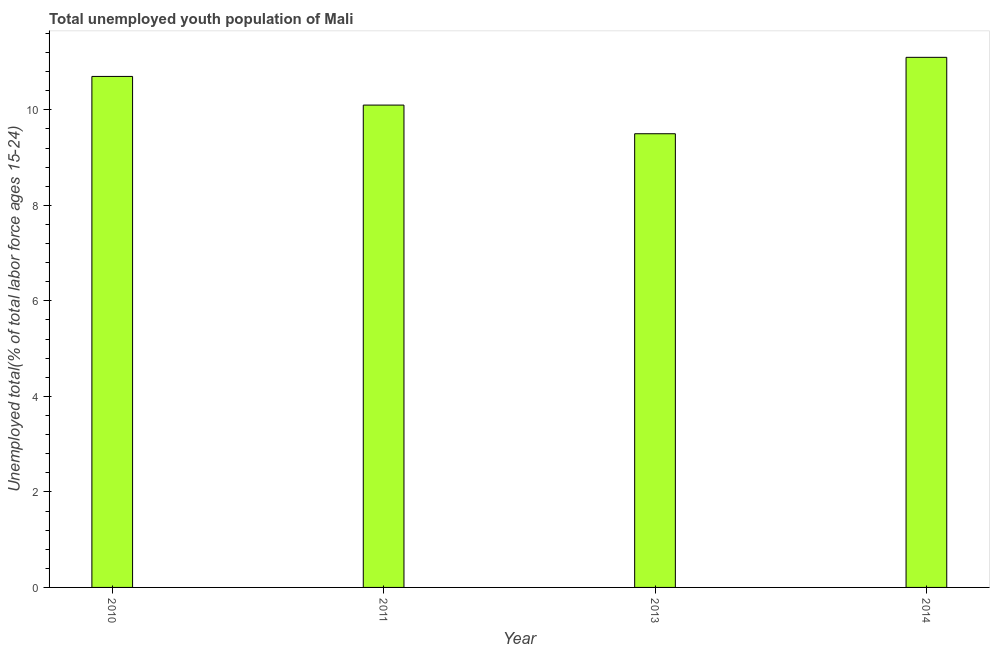Does the graph contain grids?
Provide a succinct answer. No. What is the title of the graph?
Ensure brevity in your answer.  Total unemployed youth population of Mali. What is the label or title of the Y-axis?
Offer a very short reply. Unemployed total(% of total labor force ages 15-24). Across all years, what is the maximum unemployed youth?
Ensure brevity in your answer.  11.1. Across all years, what is the minimum unemployed youth?
Keep it short and to the point. 9.5. What is the sum of the unemployed youth?
Ensure brevity in your answer.  41.4. What is the average unemployed youth per year?
Give a very brief answer. 10.35. What is the median unemployed youth?
Provide a succinct answer. 10.4. Do a majority of the years between 2014 and 2013 (inclusive) have unemployed youth greater than 8.4 %?
Offer a very short reply. No. What is the ratio of the unemployed youth in 2010 to that in 2013?
Keep it short and to the point. 1.13. Is the unemployed youth in 2011 less than that in 2014?
Keep it short and to the point. Yes. Is the difference between the unemployed youth in 2011 and 2014 greater than the difference between any two years?
Keep it short and to the point. No. What is the difference between the highest and the second highest unemployed youth?
Offer a very short reply. 0.4. What is the difference between the highest and the lowest unemployed youth?
Make the answer very short. 1.6. In how many years, is the unemployed youth greater than the average unemployed youth taken over all years?
Offer a very short reply. 2. What is the difference between two consecutive major ticks on the Y-axis?
Provide a succinct answer. 2. Are the values on the major ticks of Y-axis written in scientific E-notation?
Ensure brevity in your answer.  No. What is the Unemployed total(% of total labor force ages 15-24) of 2010?
Offer a very short reply. 10.7. What is the Unemployed total(% of total labor force ages 15-24) of 2011?
Offer a very short reply. 10.1. What is the Unemployed total(% of total labor force ages 15-24) in 2013?
Offer a very short reply. 9.5. What is the Unemployed total(% of total labor force ages 15-24) in 2014?
Provide a short and direct response. 11.1. What is the difference between the Unemployed total(% of total labor force ages 15-24) in 2010 and 2013?
Provide a short and direct response. 1.2. What is the difference between the Unemployed total(% of total labor force ages 15-24) in 2010 and 2014?
Ensure brevity in your answer.  -0.4. What is the difference between the Unemployed total(% of total labor force ages 15-24) in 2011 and 2014?
Your response must be concise. -1. What is the ratio of the Unemployed total(% of total labor force ages 15-24) in 2010 to that in 2011?
Offer a very short reply. 1.06. What is the ratio of the Unemployed total(% of total labor force ages 15-24) in 2010 to that in 2013?
Give a very brief answer. 1.13. What is the ratio of the Unemployed total(% of total labor force ages 15-24) in 2010 to that in 2014?
Provide a succinct answer. 0.96. What is the ratio of the Unemployed total(% of total labor force ages 15-24) in 2011 to that in 2013?
Provide a succinct answer. 1.06. What is the ratio of the Unemployed total(% of total labor force ages 15-24) in 2011 to that in 2014?
Provide a succinct answer. 0.91. What is the ratio of the Unemployed total(% of total labor force ages 15-24) in 2013 to that in 2014?
Your answer should be compact. 0.86. 